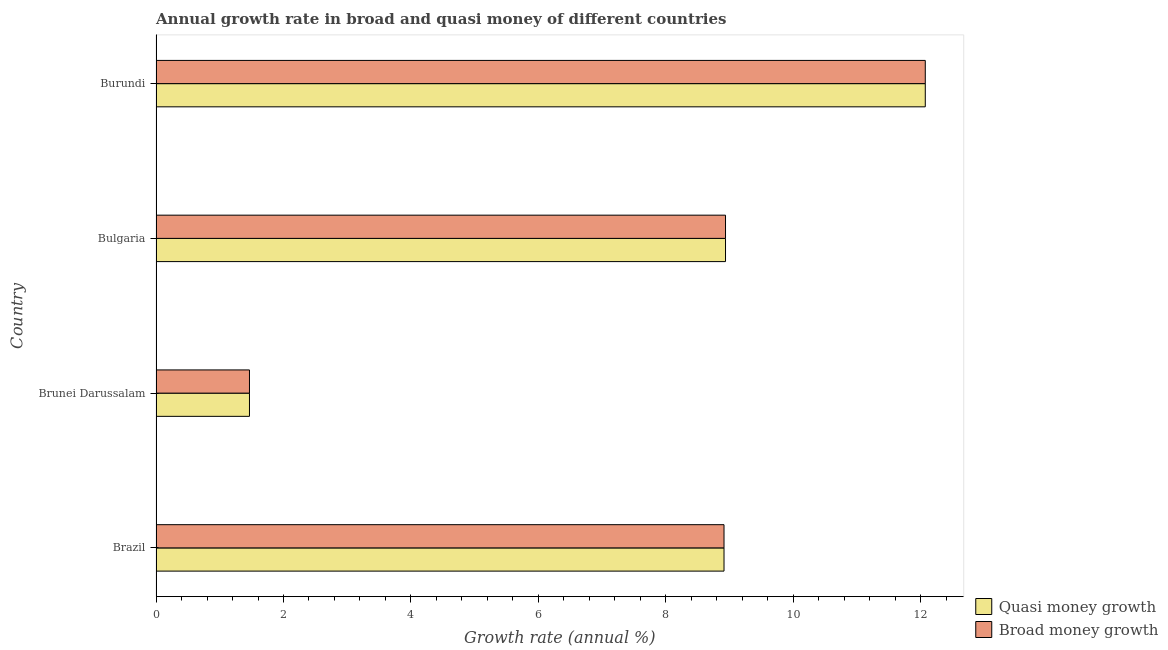How many different coloured bars are there?
Keep it short and to the point. 2. How many groups of bars are there?
Offer a terse response. 4. Are the number of bars per tick equal to the number of legend labels?
Your answer should be compact. Yes. Are the number of bars on each tick of the Y-axis equal?
Your response must be concise. Yes. In how many cases, is the number of bars for a given country not equal to the number of legend labels?
Give a very brief answer. 0. What is the annual growth rate in broad money in Bulgaria?
Provide a short and direct response. 8.94. Across all countries, what is the maximum annual growth rate in broad money?
Keep it short and to the point. 12.07. Across all countries, what is the minimum annual growth rate in broad money?
Provide a short and direct response. 1.47. In which country was the annual growth rate in quasi money maximum?
Make the answer very short. Burundi. In which country was the annual growth rate in quasi money minimum?
Your answer should be compact. Brunei Darussalam. What is the total annual growth rate in quasi money in the graph?
Provide a short and direct response. 31.38. What is the difference between the annual growth rate in broad money in Bulgaria and that in Burundi?
Your response must be concise. -3.13. What is the difference between the annual growth rate in quasi money in Bulgaria and the annual growth rate in broad money in Brunei Darussalam?
Keep it short and to the point. 7.47. What is the average annual growth rate in broad money per country?
Offer a very short reply. 7.85. What is the ratio of the annual growth rate in quasi money in Brazil to that in Brunei Darussalam?
Ensure brevity in your answer.  6.08. Is the difference between the annual growth rate in quasi money in Brazil and Brunei Darussalam greater than the difference between the annual growth rate in broad money in Brazil and Brunei Darussalam?
Provide a short and direct response. No. What is the difference between the highest and the second highest annual growth rate in broad money?
Provide a succinct answer. 3.13. What is the difference between the highest and the lowest annual growth rate in broad money?
Provide a short and direct response. 10.6. What does the 2nd bar from the top in Burundi represents?
Offer a terse response. Quasi money growth. What does the 2nd bar from the bottom in Bulgaria represents?
Ensure brevity in your answer.  Broad money growth. What is the difference between two consecutive major ticks on the X-axis?
Make the answer very short. 2. Are the values on the major ticks of X-axis written in scientific E-notation?
Your answer should be compact. No. Does the graph contain any zero values?
Your response must be concise. No. Where does the legend appear in the graph?
Your response must be concise. Bottom right. How many legend labels are there?
Provide a succinct answer. 2. What is the title of the graph?
Provide a short and direct response. Annual growth rate in broad and quasi money of different countries. What is the label or title of the X-axis?
Keep it short and to the point. Growth rate (annual %). What is the label or title of the Y-axis?
Offer a very short reply. Country. What is the Growth rate (annual %) of Quasi money growth in Brazil?
Give a very brief answer. 8.91. What is the Growth rate (annual %) in Broad money growth in Brazil?
Provide a succinct answer. 8.91. What is the Growth rate (annual %) in Quasi money growth in Brunei Darussalam?
Make the answer very short. 1.47. What is the Growth rate (annual %) in Broad money growth in Brunei Darussalam?
Your answer should be compact. 1.47. What is the Growth rate (annual %) in Quasi money growth in Bulgaria?
Provide a succinct answer. 8.94. What is the Growth rate (annual %) in Broad money growth in Bulgaria?
Keep it short and to the point. 8.94. What is the Growth rate (annual %) of Quasi money growth in Burundi?
Give a very brief answer. 12.07. What is the Growth rate (annual %) of Broad money growth in Burundi?
Provide a succinct answer. 12.07. Across all countries, what is the maximum Growth rate (annual %) of Quasi money growth?
Offer a terse response. 12.07. Across all countries, what is the maximum Growth rate (annual %) of Broad money growth?
Provide a short and direct response. 12.07. Across all countries, what is the minimum Growth rate (annual %) of Quasi money growth?
Give a very brief answer. 1.47. Across all countries, what is the minimum Growth rate (annual %) of Broad money growth?
Make the answer very short. 1.47. What is the total Growth rate (annual %) of Quasi money growth in the graph?
Make the answer very short. 31.38. What is the total Growth rate (annual %) in Broad money growth in the graph?
Ensure brevity in your answer.  31.38. What is the difference between the Growth rate (annual %) of Quasi money growth in Brazil and that in Brunei Darussalam?
Offer a very short reply. 7.45. What is the difference between the Growth rate (annual %) of Broad money growth in Brazil and that in Brunei Darussalam?
Offer a very short reply. 7.45. What is the difference between the Growth rate (annual %) of Quasi money growth in Brazil and that in Bulgaria?
Your response must be concise. -0.02. What is the difference between the Growth rate (annual %) of Broad money growth in Brazil and that in Bulgaria?
Your answer should be compact. -0.02. What is the difference between the Growth rate (annual %) of Quasi money growth in Brazil and that in Burundi?
Your answer should be compact. -3.16. What is the difference between the Growth rate (annual %) in Broad money growth in Brazil and that in Burundi?
Provide a short and direct response. -3.16. What is the difference between the Growth rate (annual %) in Quasi money growth in Brunei Darussalam and that in Bulgaria?
Provide a short and direct response. -7.47. What is the difference between the Growth rate (annual %) of Broad money growth in Brunei Darussalam and that in Bulgaria?
Give a very brief answer. -7.47. What is the difference between the Growth rate (annual %) of Quasi money growth in Brunei Darussalam and that in Burundi?
Make the answer very short. -10.6. What is the difference between the Growth rate (annual %) in Broad money growth in Brunei Darussalam and that in Burundi?
Ensure brevity in your answer.  -10.6. What is the difference between the Growth rate (annual %) in Quasi money growth in Bulgaria and that in Burundi?
Give a very brief answer. -3.13. What is the difference between the Growth rate (annual %) in Broad money growth in Bulgaria and that in Burundi?
Provide a succinct answer. -3.13. What is the difference between the Growth rate (annual %) of Quasi money growth in Brazil and the Growth rate (annual %) of Broad money growth in Brunei Darussalam?
Make the answer very short. 7.45. What is the difference between the Growth rate (annual %) of Quasi money growth in Brazil and the Growth rate (annual %) of Broad money growth in Bulgaria?
Offer a very short reply. -0.02. What is the difference between the Growth rate (annual %) in Quasi money growth in Brazil and the Growth rate (annual %) in Broad money growth in Burundi?
Make the answer very short. -3.16. What is the difference between the Growth rate (annual %) of Quasi money growth in Brunei Darussalam and the Growth rate (annual %) of Broad money growth in Bulgaria?
Make the answer very short. -7.47. What is the difference between the Growth rate (annual %) in Quasi money growth in Brunei Darussalam and the Growth rate (annual %) in Broad money growth in Burundi?
Your answer should be compact. -10.6. What is the difference between the Growth rate (annual %) of Quasi money growth in Bulgaria and the Growth rate (annual %) of Broad money growth in Burundi?
Keep it short and to the point. -3.13. What is the average Growth rate (annual %) of Quasi money growth per country?
Ensure brevity in your answer.  7.85. What is the average Growth rate (annual %) of Broad money growth per country?
Provide a short and direct response. 7.85. What is the difference between the Growth rate (annual %) in Quasi money growth and Growth rate (annual %) in Broad money growth in Bulgaria?
Offer a terse response. 0. What is the ratio of the Growth rate (annual %) of Quasi money growth in Brazil to that in Brunei Darussalam?
Keep it short and to the point. 6.08. What is the ratio of the Growth rate (annual %) in Broad money growth in Brazil to that in Brunei Darussalam?
Provide a short and direct response. 6.08. What is the ratio of the Growth rate (annual %) of Quasi money growth in Brazil to that in Burundi?
Give a very brief answer. 0.74. What is the ratio of the Growth rate (annual %) of Broad money growth in Brazil to that in Burundi?
Keep it short and to the point. 0.74. What is the ratio of the Growth rate (annual %) of Quasi money growth in Brunei Darussalam to that in Bulgaria?
Your answer should be compact. 0.16. What is the ratio of the Growth rate (annual %) in Broad money growth in Brunei Darussalam to that in Bulgaria?
Your answer should be very brief. 0.16. What is the ratio of the Growth rate (annual %) of Quasi money growth in Brunei Darussalam to that in Burundi?
Ensure brevity in your answer.  0.12. What is the ratio of the Growth rate (annual %) of Broad money growth in Brunei Darussalam to that in Burundi?
Keep it short and to the point. 0.12. What is the ratio of the Growth rate (annual %) of Quasi money growth in Bulgaria to that in Burundi?
Provide a succinct answer. 0.74. What is the ratio of the Growth rate (annual %) in Broad money growth in Bulgaria to that in Burundi?
Offer a very short reply. 0.74. What is the difference between the highest and the second highest Growth rate (annual %) of Quasi money growth?
Offer a very short reply. 3.13. What is the difference between the highest and the second highest Growth rate (annual %) of Broad money growth?
Make the answer very short. 3.13. What is the difference between the highest and the lowest Growth rate (annual %) in Quasi money growth?
Keep it short and to the point. 10.6. What is the difference between the highest and the lowest Growth rate (annual %) of Broad money growth?
Your answer should be compact. 10.6. 